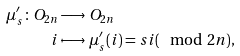<formula> <loc_0><loc_0><loc_500><loc_500>\mu _ { s } ^ { \prime } \colon O _ { 2 n } & \longrightarrow O _ { 2 n } \\ i & \longmapsto \mu _ { s } ^ { \prime } ( i ) = s i ( \mod 2 n ) ,</formula> 